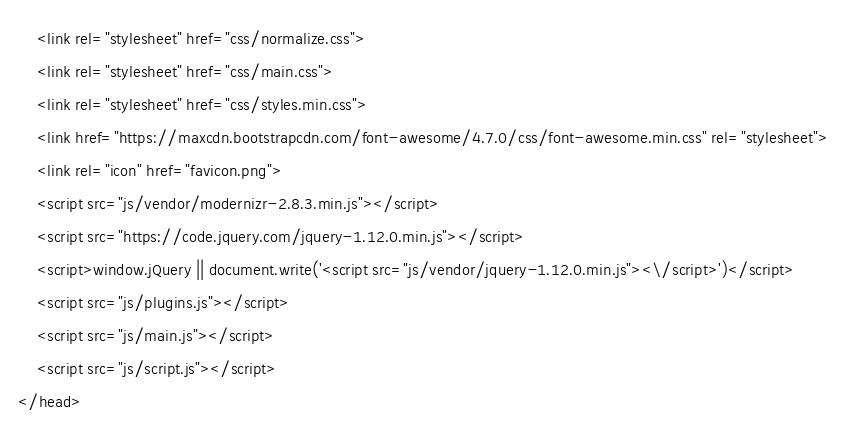<code> <loc_0><loc_0><loc_500><loc_500><_PHP_>    <link rel="stylesheet" href="css/normalize.css">
    <link rel="stylesheet" href="css/main.css">
    <link rel="stylesheet" href="css/styles.min.css">
    <link href="https://maxcdn.bootstrapcdn.com/font-awesome/4.7.0/css/font-awesome.min.css" rel="stylesheet">
    <link rel="icon" href="favicon.png">
    <script src="js/vendor/modernizr-2.8.3.min.js"></script>
    <script src="https://code.jquery.com/jquery-1.12.0.min.js"></script>
    <script>window.jQuery || document.write('<script src="js/vendor/jquery-1.12.0.min.js"><\/script>')</script>
    <script src="js/plugins.js"></script>
    <script src="js/main.js"></script>
    <script src="js/script.js"></script>
</head></code> 